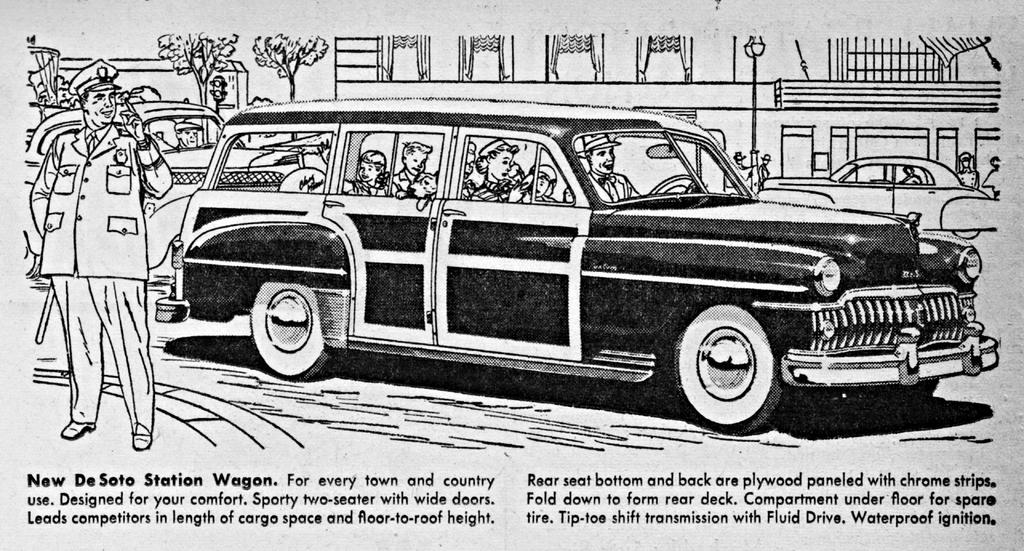What type of content is depicted in the image? There are diagrams in the image. What elements are included in the diagrams? The diagrams contain people and vehicles. Is there any written information in the image? Yes, there is text on the paper in the image. What type of clam is being held by the minister in the image? There is no minister or clam present in the image; it contains diagrams with people and vehicles. How does the wrist of the person in the image appear? There is no specific person or wrist visible in the image; it contains diagrams with people and vehicles. 